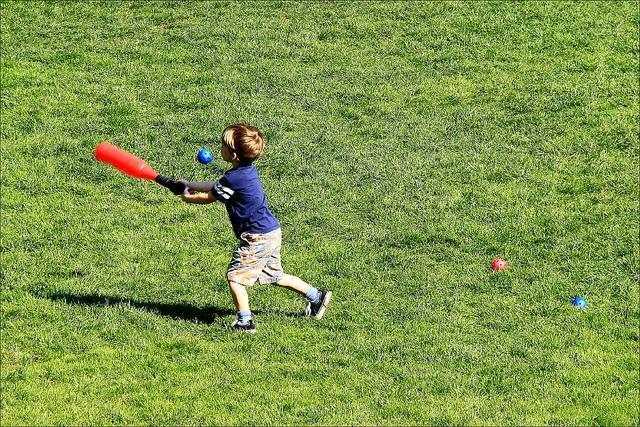How many stripes are on the boys sleeve?
Give a very brief answer. 2. How many people are there?
Give a very brief answer. 1. 